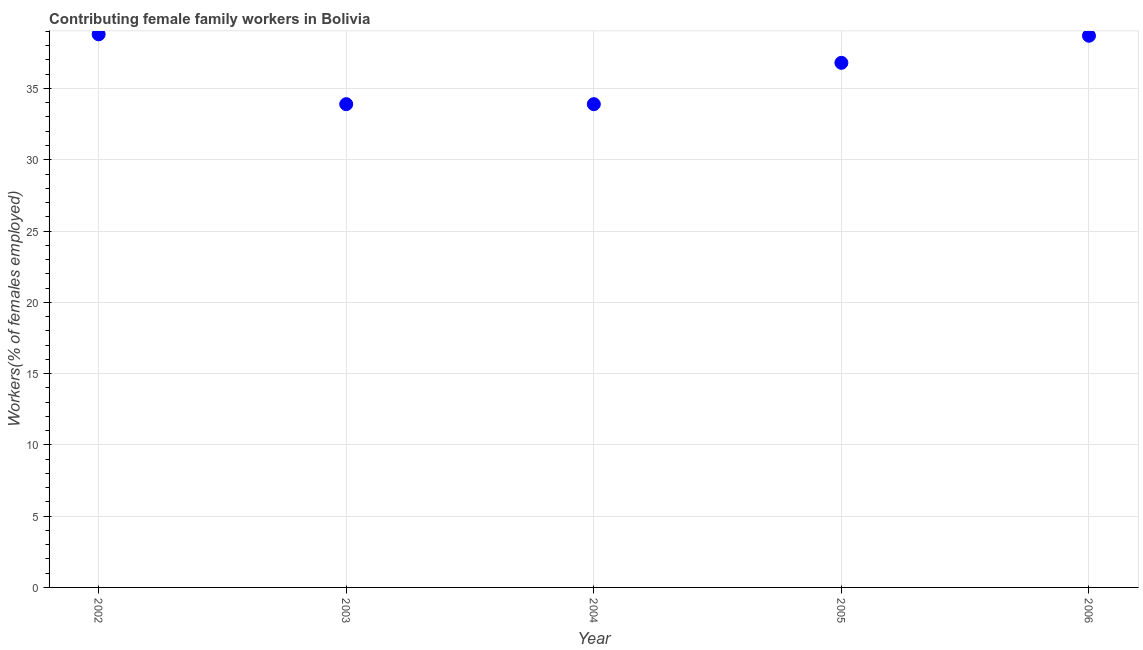What is the contributing female family workers in 2003?
Make the answer very short. 33.9. Across all years, what is the maximum contributing female family workers?
Offer a very short reply. 38.8. Across all years, what is the minimum contributing female family workers?
Offer a terse response. 33.9. In which year was the contributing female family workers minimum?
Ensure brevity in your answer.  2003. What is the sum of the contributing female family workers?
Your answer should be compact. 182.1. What is the difference between the contributing female family workers in 2004 and 2005?
Offer a very short reply. -2.9. What is the average contributing female family workers per year?
Keep it short and to the point. 36.42. What is the median contributing female family workers?
Keep it short and to the point. 36.8. In how many years, is the contributing female family workers greater than 23 %?
Offer a terse response. 5. What is the ratio of the contributing female family workers in 2003 to that in 2004?
Keep it short and to the point. 1. Is the contributing female family workers in 2002 less than that in 2006?
Make the answer very short. No. What is the difference between the highest and the second highest contributing female family workers?
Your answer should be very brief. 0.1. Is the sum of the contributing female family workers in 2005 and 2006 greater than the maximum contributing female family workers across all years?
Offer a very short reply. Yes. What is the difference between the highest and the lowest contributing female family workers?
Give a very brief answer. 4.9. How many dotlines are there?
Provide a succinct answer. 1. How many years are there in the graph?
Your answer should be very brief. 5. What is the difference between two consecutive major ticks on the Y-axis?
Offer a terse response. 5. Does the graph contain grids?
Your answer should be very brief. Yes. What is the title of the graph?
Your answer should be compact. Contributing female family workers in Bolivia. What is the label or title of the Y-axis?
Provide a succinct answer. Workers(% of females employed). What is the Workers(% of females employed) in 2002?
Your answer should be very brief. 38.8. What is the Workers(% of females employed) in 2003?
Your answer should be compact. 33.9. What is the Workers(% of females employed) in 2004?
Your answer should be very brief. 33.9. What is the Workers(% of females employed) in 2005?
Your answer should be compact. 36.8. What is the Workers(% of females employed) in 2006?
Ensure brevity in your answer.  38.7. What is the difference between the Workers(% of females employed) in 2002 and 2004?
Your answer should be compact. 4.9. What is the difference between the Workers(% of females employed) in 2002 and 2005?
Keep it short and to the point. 2. What is the difference between the Workers(% of females employed) in 2003 and 2004?
Ensure brevity in your answer.  0. What is the difference between the Workers(% of females employed) in 2003 and 2005?
Ensure brevity in your answer.  -2.9. What is the difference between the Workers(% of females employed) in 2003 and 2006?
Your response must be concise. -4.8. What is the difference between the Workers(% of females employed) in 2004 and 2006?
Provide a short and direct response. -4.8. What is the difference between the Workers(% of females employed) in 2005 and 2006?
Your answer should be very brief. -1.9. What is the ratio of the Workers(% of females employed) in 2002 to that in 2003?
Your answer should be very brief. 1.15. What is the ratio of the Workers(% of females employed) in 2002 to that in 2004?
Your answer should be compact. 1.15. What is the ratio of the Workers(% of females employed) in 2002 to that in 2005?
Your answer should be compact. 1.05. What is the ratio of the Workers(% of females employed) in 2003 to that in 2004?
Your answer should be compact. 1. What is the ratio of the Workers(% of females employed) in 2003 to that in 2005?
Ensure brevity in your answer.  0.92. What is the ratio of the Workers(% of females employed) in 2003 to that in 2006?
Your response must be concise. 0.88. What is the ratio of the Workers(% of females employed) in 2004 to that in 2005?
Offer a very short reply. 0.92. What is the ratio of the Workers(% of females employed) in 2004 to that in 2006?
Your answer should be very brief. 0.88. What is the ratio of the Workers(% of females employed) in 2005 to that in 2006?
Offer a terse response. 0.95. 